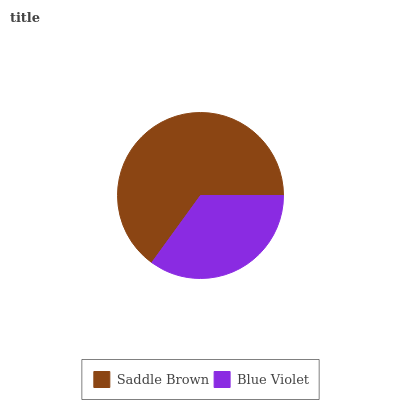Is Blue Violet the minimum?
Answer yes or no. Yes. Is Saddle Brown the maximum?
Answer yes or no. Yes. Is Blue Violet the maximum?
Answer yes or no. No. Is Saddle Brown greater than Blue Violet?
Answer yes or no. Yes. Is Blue Violet less than Saddle Brown?
Answer yes or no. Yes. Is Blue Violet greater than Saddle Brown?
Answer yes or no. No. Is Saddle Brown less than Blue Violet?
Answer yes or no. No. Is Saddle Brown the high median?
Answer yes or no. Yes. Is Blue Violet the low median?
Answer yes or no. Yes. Is Blue Violet the high median?
Answer yes or no. No. Is Saddle Brown the low median?
Answer yes or no. No. 